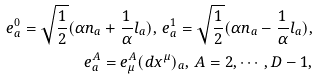Convert formula to latex. <formula><loc_0><loc_0><loc_500><loc_500>e ^ { 0 } _ { a } = \sqrt { \frac { 1 } { 2 } } ( \alpha n _ { a } + \frac { 1 } { \alpha } l _ { a } ) , \, e ^ { 1 } _ { a } = \sqrt { \frac { 1 } { 2 } } ( \alpha n _ { a } - \frac { 1 } { \alpha } l _ { a } ) , \\ e ^ { A } _ { a } = e ^ { A } _ { \mu } ( d x ^ { \mu } ) _ { a } , \, A = 2 , \cdots , D - 1 ,</formula> 